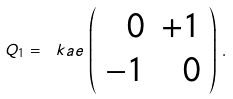<formula> <loc_0><loc_0><loc_500><loc_500>Q _ { 1 } = \ k a e \, \left ( \begin{array} { r r } 0 & + 1 \\ - 1 & 0 \end{array} \right ) \, .</formula> 